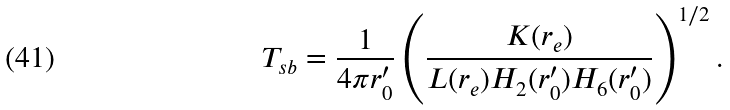<formula> <loc_0><loc_0><loc_500><loc_500>T _ { s b } = { \frac { 1 } { 4 \pi r _ { 0 } ^ { \prime } } } \left ( { \frac { K ( r _ { e } ) } { L ( r _ { e } ) H _ { 2 } ( r _ { 0 } ^ { \prime } ) H _ { 6 } ( r _ { 0 } ^ { \prime } ) } } \right ) ^ { 1 / 2 } .</formula> 